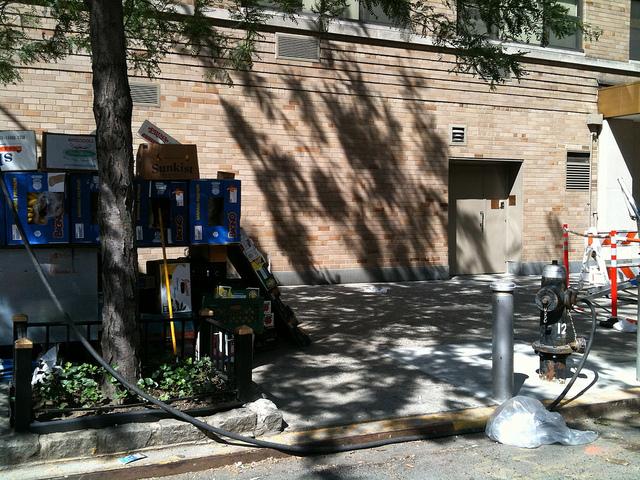Is there a brick building in the background?
Short answer required. Yes. Where are the shadows?
Short answer required. On building. Is it dark?
Give a very brief answer. No. 